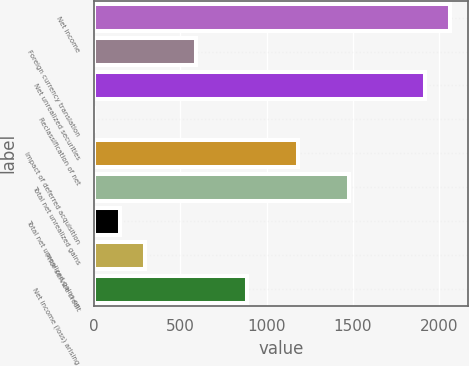Convert chart to OTSL. <chart><loc_0><loc_0><loc_500><loc_500><bar_chart><fcel>Net income<fcel>Foreign currency translation<fcel>Net unrealized securities<fcel>Reclassification of net<fcel>Impact of deferred acquisition<fcel>Total net unrealized gains<fcel>Total net unrealized gains on<fcel>Prior service credit<fcel>Net income (loss) arising<nl><fcel>2064.6<fcel>590.6<fcel>1917.2<fcel>1<fcel>1180.2<fcel>1475<fcel>148.4<fcel>295.8<fcel>885.4<nl></chart> 